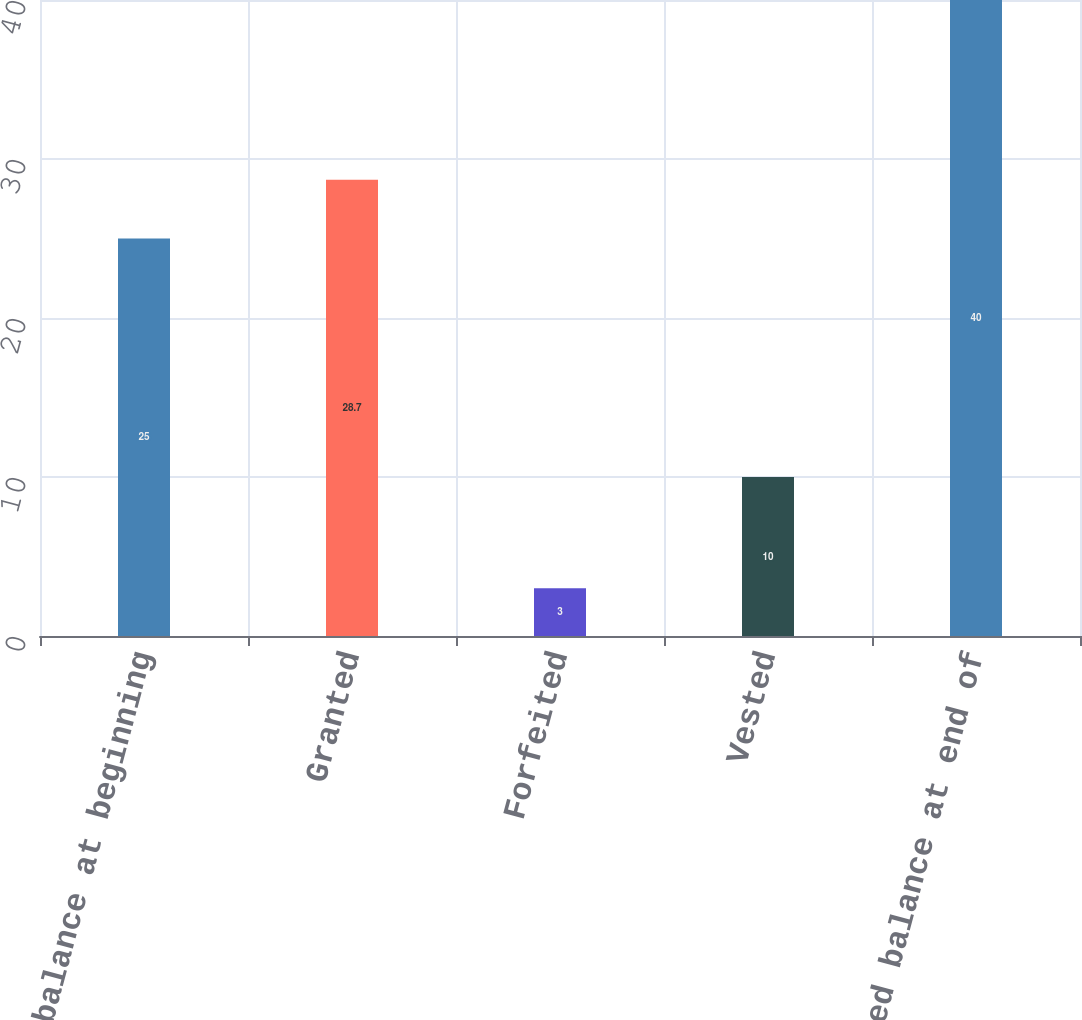Convert chart. <chart><loc_0><loc_0><loc_500><loc_500><bar_chart><fcel>Unvested balance at beginning<fcel>Granted<fcel>Forfeited<fcel>Vested<fcel>Unvested balance at end of<nl><fcel>25<fcel>28.7<fcel>3<fcel>10<fcel>40<nl></chart> 